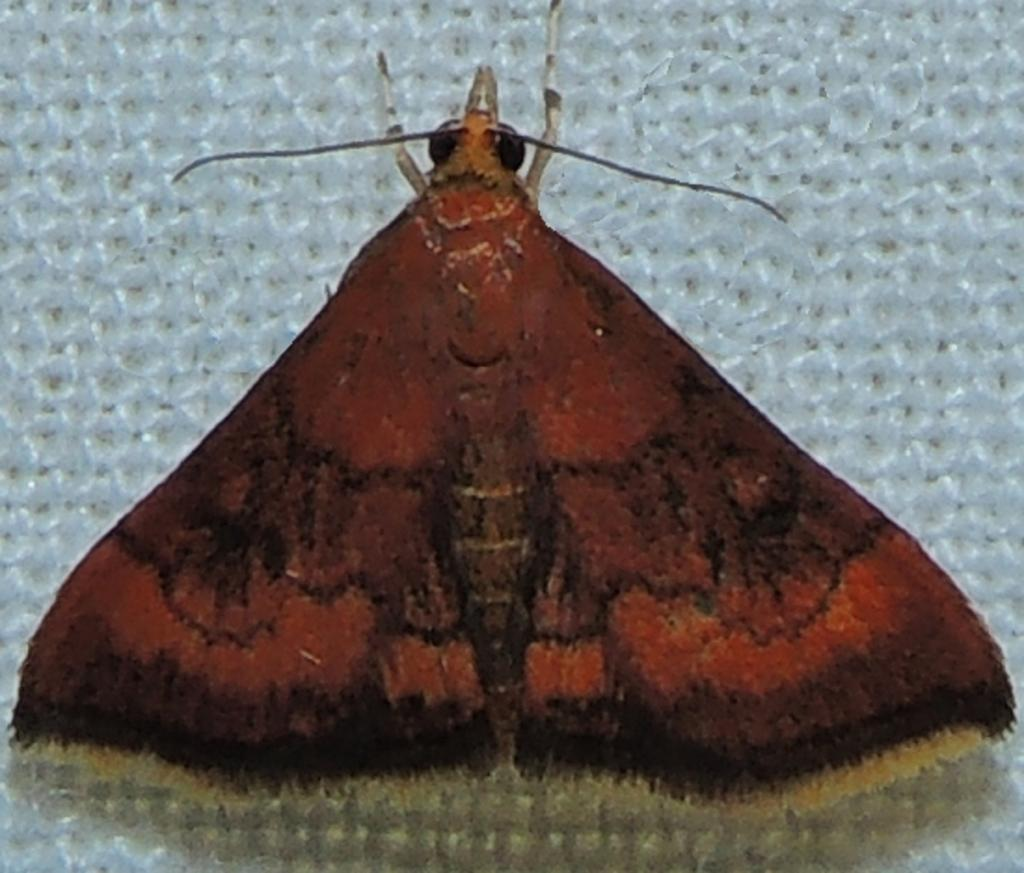What type of creature is present in the image? There is an insect in the image. What color is the insect? The insect is red in color. What is the color of the background in the image? The background of the image is white. What grade does the governor assign to the insect in the image? There is no mention of a grade or a governor in the image, so this question cannot be answered. 